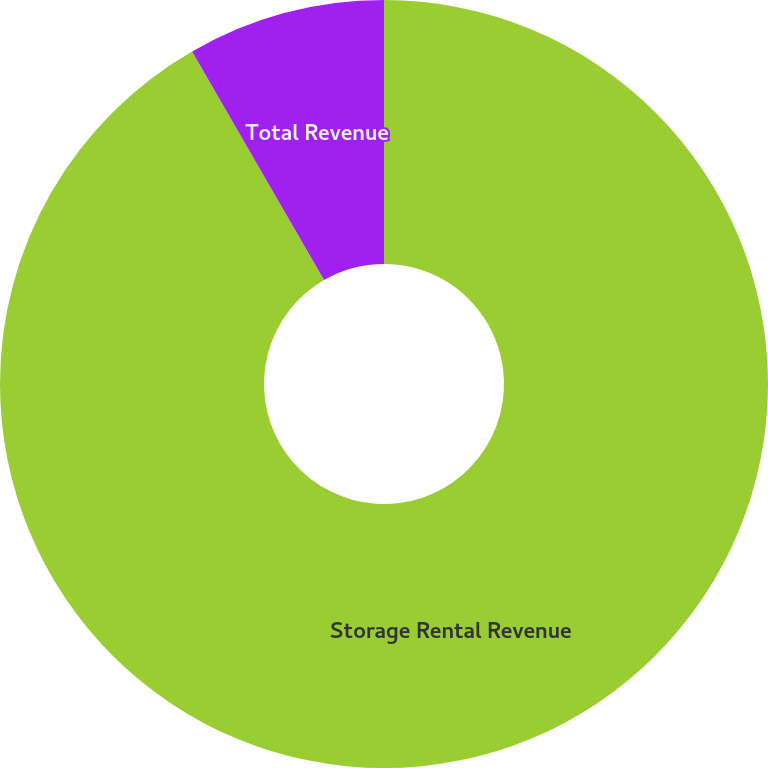Convert chart. <chart><loc_0><loc_0><loc_500><loc_500><pie_chart><fcel>Storage Rental Revenue<fcel>Total Revenue<nl><fcel>91.67%<fcel>8.33%<nl></chart> 